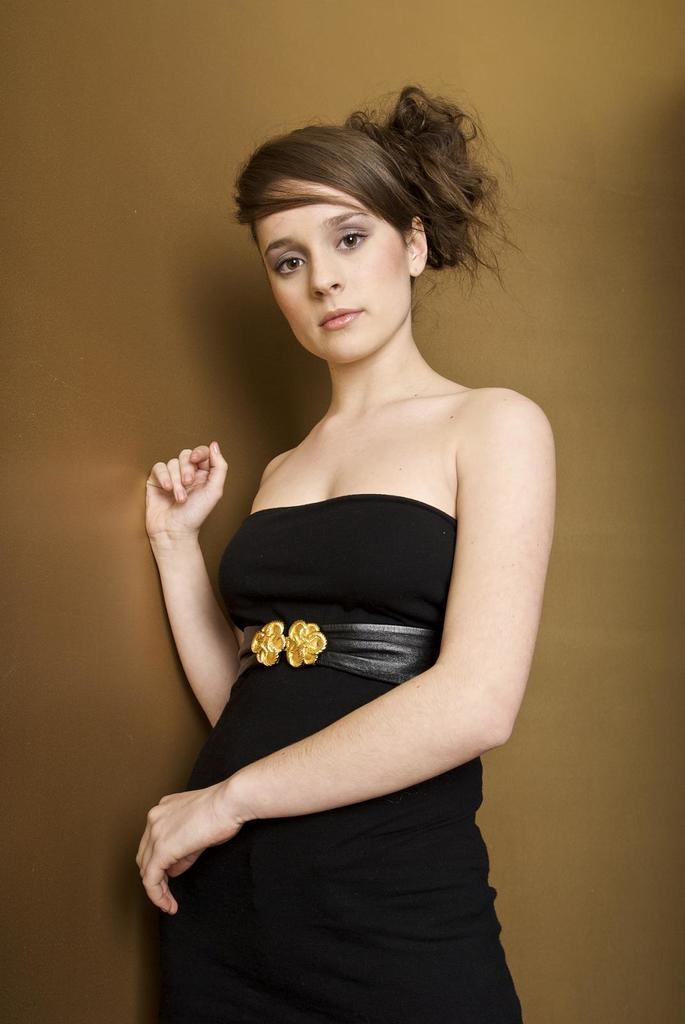Please provide a concise description of this image. In this image, I can see a woman standing. The background is light brown in color. 